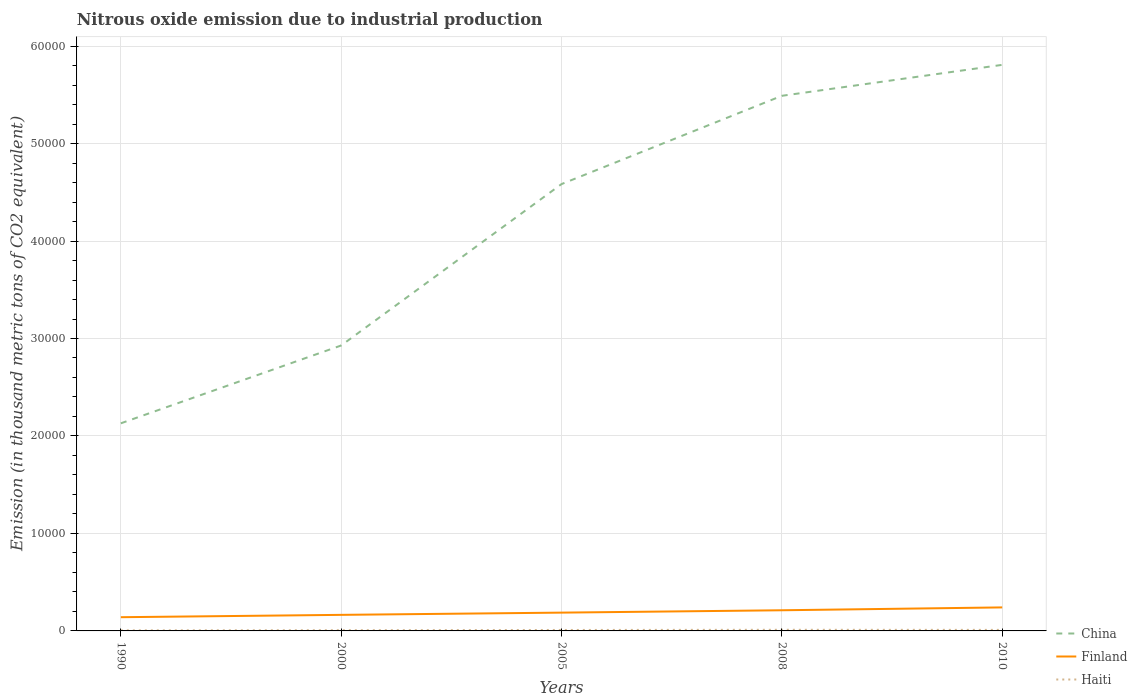Does the line corresponding to China intersect with the line corresponding to Haiti?
Make the answer very short. No. Across all years, what is the maximum amount of nitrous oxide emitted in Finland?
Your answer should be compact. 1406.8. What is the total amount of nitrous oxide emitted in Haiti in the graph?
Ensure brevity in your answer.  -23.2. What is the difference between the highest and the second highest amount of nitrous oxide emitted in Finland?
Keep it short and to the point. 1005.6. Is the amount of nitrous oxide emitted in China strictly greater than the amount of nitrous oxide emitted in Haiti over the years?
Provide a short and direct response. No. How many lines are there?
Keep it short and to the point. 3. Are the values on the major ticks of Y-axis written in scientific E-notation?
Your response must be concise. No. Does the graph contain grids?
Your response must be concise. Yes. Where does the legend appear in the graph?
Provide a short and direct response. Bottom right. How many legend labels are there?
Make the answer very short. 3. How are the legend labels stacked?
Offer a very short reply. Vertical. What is the title of the graph?
Give a very brief answer. Nitrous oxide emission due to industrial production. Does "Solomon Islands" appear as one of the legend labels in the graph?
Provide a short and direct response. No. What is the label or title of the X-axis?
Your response must be concise. Years. What is the label or title of the Y-axis?
Give a very brief answer. Emission (in thousand metric tons of CO2 equivalent). What is the Emission (in thousand metric tons of CO2 equivalent) of China in 1990?
Ensure brevity in your answer.  2.13e+04. What is the Emission (in thousand metric tons of CO2 equivalent) in Finland in 1990?
Keep it short and to the point. 1406.8. What is the Emission (in thousand metric tons of CO2 equivalent) in Haiti in 1990?
Your answer should be compact. 56.6. What is the Emission (in thousand metric tons of CO2 equivalent) of China in 2000?
Provide a short and direct response. 2.93e+04. What is the Emission (in thousand metric tons of CO2 equivalent) in Finland in 2000?
Keep it short and to the point. 1648.4. What is the Emission (in thousand metric tons of CO2 equivalent) in Haiti in 2000?
Your answer should be very brief. 73.8. What is the Emission (in thousand metric tons of CO2 equivalent) in China in 2005?
Your answer should be compact. 4.58e+04. What is the Emission (in thousand metric tons of CO2 equivalent) of Finland in 2005?
Offer a very short reply. 1876.3. What is the Emission (in thousand metric tons of CO2 equivalent) of Haiti in 2005?
Make the answer very short. 97. What is the Emission (in thousand metric tons of CO2 equivalent) of China in 2008?
Make the answer very short. 5.49e+04. What is the Emission (in thousand metric tons of CO2 equivalent) of Finland in 2008?
Offer a very short reply. 2118.7. What is the Emission (in thousand metric tons of CO2 equivalent) of Haiti in 2008?
Make the answer very short. 116. What is the Emission (in thousand metric tons of CO2 equivalent) in China in 2010?
Offer a terse response. 5.81e+04. What is the Emission (in thousand metric tons of CO2 equivalent) in Finland in 2010?
Offer a terse response. 2412.4. What is the Emission (in thousand metric tons of CO2 equivalent) of Haiti in 2010?
Offer a very short reply. 105.8. Across all years, what is the maximum Emission (in thousand metric tons of CO2 equivalent) of China?
Give a very brief answer. 5.81e+04. Across all years, what is the maximum Emission (in thousand metric tons of CO2 equivalent) in Finland?
Provide a succinct answer. 2412.4. Across all years, what is the maximum Emission (in thousand metric tons of CO2 equivalent) in Haiti?
Offer a very short reply. 116. Across all years, what is the minimum Emission (in thousand metric tons of CO2 equivalent) of China?
Provide a short and direct response. 2.13e+04. Across all years, what is the minimum Emission (in thousand metric tons of CO2 equivalent) of Finland?
Ensure brevity in your answer.  1406.8. Across all years, what is the minimum Emission (in thousand metric tons of CO2 equivalent) in Haiti?
Give a very brief answer. 56.6. What is the total Emission (in thousand metric tons of CO2 equivalent) of China in the graph?
Your answer should be very brief. 2.09e+05. What is the total Emission (in thousand metric tons of CO2 equivalent) in Finland in the graph?
Your response must be concise. 9462.6. What is the total Emission (in thousand metric tons of CO2 equivalent) of Haiti in the graph?
Offer a terse response. 449.2. What is the difference between the Emission (in thousand metric tons of CO2 equivalent) in China in 1990 and that in 2000?
Your response must be concise. -7984.9. What is the difference between the Emission (in thousand metric tons of CO2 equivalent) in Finland in 1990 and that in 2000?
Offer a very short reply. -241.6. What is the difference between the Emission (in thousand metric tons of CO2 equivalent) of Haiti in 1990 and that in 2000?
Offer a terse response. -17.2. What is the difference between the Emission (in thousand metric tons of CO2 equivalent) in China in 1990 and that in 2005?
Offer a very short reply. -2.45e+04. What is the difference between the Emission (in thousand metric tons of CO2 equivalent) in Finland in 1990 and that in 2005?
Your answer should be compact. -469.5. What is the difference between the Emission (in thousand metric tons of CO2 equivalent) in Haiti in 1990 and that in 2005?
Your answer should be very brief. -40.4. What is the difference between the Emission (in thousand metric tons of CO2 equivalent) of China in 1990 and that in 2008?
Provide a succinct answer. -3.36e+04. What is the difference between the Emission (in thousand metric tons of CO2 equivalent) in Finland in 1990 and that in 2008?
Provide a succinct answer. -711.9. What is the difference between the Emission (in thousand metric tons of CO2 equivalent) of Haiti in 1990 and that in 2008?
Ensure brevity in your answer.  -59.4. What is the difference between the Emission (in thousand metric tons of CO2 equivalent) of China in 1990 and that in 2010?
Your response must be concise. -3.68e+04. What is the difference between the Emission (in thousand metric tons of CO2 equivalent) of Finland in 1990 and that in 2010?
Your response must be concise. -1005.6. What is the difference between the Emission (in thousand metric tons of CO2 equivalent) of Haiti in 1990 and that in 2010?
Provide a succinct answer. -49.2. What is the difference between the Emission (in thousand metric tons of CO2 equivalent) of China in 2000 and that in 2005?
Your response must be concise. -1.66e+04. What is the difference between the Emission (in thousand metric tons of CO2 equivalent) in Finland in 2000 and that in 2005?
Provide a short and direct response. -227.9. What is the difference between the Emission (in thousand metric tons of CO2 equivalent) in Haiti in 2000 and that in 2005?
Your response must be concise. -23.2. What is the difference between the Emission (in thousand metric tons of CO2 equivalent) in China in 2000 and that in 2008?
Provide a succinct answer. -2.56e+04. What is the difference between the Emission (in thousand metric tons of CO2 equivalent) of Finland in 2000 and that in 2008?
Make the answer very short. -470.3. What is the difference between the Emission (in thousand metric tons of CO2 equivalent) of Haiti in 2000 and that in 2008?
Make the answer very short. -42.2. What is the difference between the Emission (in thousand metric tons of CO2 equivalent) in China in 2000 and that in 2010?
Provide a succinct answer. -2.88e+04. What is the difference between the Emission (in thousand metric tons of CO2 equivalent) in Finland in 2000 and that in 2010?
Provide a succinct answer. -764. What is the difference between the Emission (in thousand metric tons of CO2 equivalent) in Haiti in 2000 and that in 2010?
Ensure brevity in your answer.  -32. What is the difference between the Emission (in thousand metric tons of CO2 equivalent) of China in 2005 and that in 2008?
Keep it short and to the point. -9056.8. What is the difference between the Emission (in thousand metric tons of CO2 equivalent) in Finland in 2005 and that in 2008?
Provide a short and direct response. -242.4. What is the difference between the Emission (in thousand metric tons of CO2 equivalent) of Haiti in 2005 and that in 2008?
Offer a very short reply. -19. What is the difference between the Emission (in thousand metric tons of CO2 equivalent) of China in 2005 and that in 2010?
Ensure brevity in your answer.  -1.22e+04. What is the difference between the Emission (in thousand metric tons of CO2 equivalent) in Finland in 2005 and that in 2010?
Your answer should be very brief. -536.1. What is the difference between the Emission (in thousand metric tons of CO2 equivalent) of Haiti in 2005 and that in 2010?
Your response must be concise. -8.8. What is the difference between the Emission (in thousand metric tons of CO2 equivalent) of China in 2008 and that in 2010?
Ensure brevity in your answer.  -3175.5. What is the difference between the Emission (in thousand metric tons of CO2 equivalent) of Finland in 2008 and that in 2010?
Provide a short and direct response. -293.7. What is the difference between the Emission (in thousand metric tons of CO2 equivalent) in Haiti in 2008 and that in 2010?
Ensure brevity in your answer.  10.2. What is the difference between the Emission (in thousand metric tons of CO2 equivalent) of China in 1990 and the Emission (in thousand metric tons of CO2 equivalent) of Finland in 2000?
Keep it short and to the point. 1.97e+04. What is the difference between the Emission (in thousand metric tons of CO2 equivalent) of China in 1990 and the Emission (in thousand metric tons of CO2 equivalent) of Haiti in 2000?
Make the answer very short. 2.12e+04. What is the difference between the Emission (in thousand metric tons of CO2 equivalent) of Finland in 1990 and the Emission (in thousand metric tons of CO2 equivalent) of Haiti in 2000?
Give a very brief answer. 1333. What is the difference between the Emission (in thousand metric tons of CO2 equivalent) of China in 1990 and the Emission (in thousand metric tons of CO2 equivalent) of Finland in 2005?
Your answer should be compact. 1.94e+04. What is the difference between the Emission (in thousand metric tons of CO2 equivalent) of China in 1990 and the Emission (in thousand metric tons of CO2 equivalent) of Haiti in 2005?
Provide a succinct answer. 2.12e+04. What is the difference between the Emission (in thousand metric tons of CO2 equivalent) in Finland in 1990 and the Emission (in thousand metric tons of CO2 equivalent) in Haiti in 2005?
Provide a short and direct response. 1309.8. What is the difference between the Emission (in thousand metric tons of CO2 equivalent) of China in 1990 and the Emission (in thousand metric tons of CO2 equivalent) of Finland in 2008?
Make the answer very short. 1.92e+04. What is the difference between the Emission (in thousand metric tons of CO2 equivalent) in China in 1990 and the Emission (in thousand metric tons of CO2 equivalent) in Haiti in 2008?
Give a very brief answer. 2.12e+04. What is the difference between the Emission (in thousand metric tons of CO2 equivalent) of Finland in 1990 and the Emission (in thousand metric tons of CO2 equivalent) of Haiti in 2008?
Your answer should be compact. 1290.8. What is the difference between the Emission (in thousand metric tons of CO2 equivalent) of China in 1990 and the Emission (in thousand metric tons of CO2 equivalent) of Finland in 2010?
Make the answer very short. 1.89e+04. What is the difference between the Emission (in thousand metric tons of CO2 equivalent) in China in 1990 and the Emission (in thousand metric tons of CO2 equivalent) in Haiti in 2010?
Your answer should be compact. 2.12e+04. What is the difference between the Emission (in thousand metric tons of CO2 equivalent) of Finland in 1990 and the Emission (in thousand metric tons of CO2 equivalent) of Haiti in 2010?
Your answer should be very brief. 1301. What is the difference between the Emission (in thousand metric tons of CO2 equivalent) of China in 2000 and the Emission (in thousand metric tons of CO2 equivalent) of Finland in 2005?
Offer a very short reply. 2.74e+04. What is the difference between the Emission (in thousand metric tons of CO2 equivalent) in China in 2000 and the Emission (in thousand metric tons of CO2 equivalent) in Haiti in 2005?
Provide a short and direct response. 2.92e+04. What is the difference between the Emission (in thousand metric tons of CO2 equivalent) in Finland in 2000 and the Emission (in thousand metric tons of CO2 equivalent) in Haiti in 2005?
Give a very brief answer. 1551.4. What is the difference between the Emission (in thousand metric tons of CO2 equivalent) in China in 2000 and the Emission (in thousand metric tons of CO2 equivalent) in Finland in 2008?
Make the answer very short. 2.72e+04. What is the difference between the Emission (in thousand metric tons of CO2 equivalent) of China in 2000 and the Emission (in thousand metric tons of CO2 equivalent) of Haiti in 2008?
Your answer should be very brief. 2.92e+04. What is the difference between the Emission (in thousand metric tons of CO2 equivalent) in Finland in 2000 and the Emission (in thousand metric tons of CO2 equivalent) in Haiti in 2008?
Ensure brevity in your answer.  1532.4. What is the difference between the Emission (in thousand metric tons of CO2 equivalent) of China in 2000 and the Emission (in thousand metric tons of CO2 equivalent) of Finland in 2010?
Your answer should be compact. 2.69e+04. What is the difference between the Emission (in thousand metric tons of CO2 equivalent) in China in 2000 and the Emission (in thousand metric tons of CO2 equivalent) in Haiti in 2010?
Make the answer very short. 2.92e+04. What is the difference between the Emission (in thousand metric tons of CO2 equivalent) of Finland in 2000 and the Emission (in thousand metric tons of CO2 equivalent) of Haiti in 2010?
Offer a terse response. 1542.6. What is the difference between the Emission (in thousand metric tons of CO2 equivalent) of China in 2005 and the Emission (in thousand metric tons of CO2 equivalent) of Finland in 2008?
Keep it short and to the point. 4.37e+04. What is the difference between the Emission (in thousand metric tons of CO2 equivalent) in China in 2005 and the Emission (in thousand metric tons of CO2 equivalent) in Haiti in 2008?
Keep it short and to the point. 4.57e+04. What is the difference between the Emission (in thousand metric tons of CO2 equivalent) in Finland in 2005 and the Emission (in thousand metric tons of CO2 equivalent) in Haiti in 2008?
Provide a short and direct response. 1760.3. What is the difference between the Emission (in thousand metric tons of CO2 equivalent) in China in 2005 and the Emission (in thousand metric tons of CO2 equivalent) in Finland in 2010?
Ensure brevity in your answer.  4.34e+04. What is the difference between the Emission (in thousand metric tons of CO2 equivalent) in China in 2005 and the Emission (in thousand metric tons of CO2 equivalent) in Haiti in 2010?
Your answer should be compact. 4.57e+04. What is the difference between the Emission (in thousand metric tons of CO2 equivalent) in Finland in 2005 and the Emission (in thousand metric tons of CO2 equivalent) in Haiti in 2010?
Make the answer very short. 1770.5. What is the difference between the Emission (in thousand metric tons of CO2 equivalent) in China in 2008 and the Emission (in thousand metric tons of CO2 equivalent) in Finland in 2010?
Your answer should be very brief. 5.25e+04. What is the difference between the Emission (in thousand metric tons of CO2 equivalent) in China in 2008 and the Emission (in thousand metric tons of CO2 equivalent) in Haiti in 2010?
Ensure brevity in your answer.  5.48e+04. What is the difference between the Emission (in thousand metric tons of CO2 equivalent) in Finland in 2008 and the Emission (in thousand metric tons of CO2 equivalent) in Haiti in 2010?
Your response must be concise. 2012.9. What is the average Emission (in thousand metric tons of CO2 equivalent) of China per year?
Offer a terse response. 4.19e+04. What is the average Emission (in thousand metric tons of CO2 equivalent) of Finland per year?
Give a very brief answer. 1892.52. What is the average Emission (in thousand metric tons of CO2 equivalent) of Haiti per year?
Your response must be concise. 89.84. In the year 1990, what is the difference between the Emission (in thousand metric tons of CO2 equivalent) in China and Emission (in thousand metric tons of CO2 equivalent) in Finland?
Give a very brief answer. 1.99e+04. In the year 1990, what is the difference between the Emission (in thousand metric tons of CO2 equivalent) of China and Emission (in thousand metric tons of CO2 equivalent) of Haiti?
Offer a terse response. 2.12e+04. In the year 1990, what is the difference between the Emission (in thousand metric tons of CO2 equivalent) in Finland and Emission (in thousand metric tons of CO2 equivalent) in Haiti?
Ensure brevity in your answer.  1350.2. In the year 2000, what is the difference between the Emission (in thousand metric tons of CO2 equivalent) of China and Emission (in thousand metric tons of CO2 equivalent) of Finland?
Your answer should be very brief. 2.76e+04. In the year 2000, what is the difference between the Emission (in thousand metric tons of CO2 equivalent) in China and Emission (in thousand metric tons of CO2 equivalent) in Haiti?
Provide a succinct answer. 2.92e+04. In the year 2000, what is the difference between the Emission (in thousand metric tons of CO2 equivalent) of Finland and Emission (in thousand metric tons of CO2 equivalent) of Haiti?
Your answer should be very brief. 1574.6. In the year 2005, what is the difference between the Emission (in thousand metric tons of CO2 equivalent) in China and Emission (in thousand metric tons of CO2 equivalent) in Finland?
Your response must be concise. 4.40e+04. In the year 2005, what is the difference between the Emission (in thousand metric tons of CO2 equivalent) of China and Emission (in thousand metric tons of CO2 equivalent) of Haiti?
Provide a succinct answer. 4.57e+04. In the year 2005, what is the difference between the Emission (in thousand metric tons of CO2 equivalent) in Finland and Emission (in thousand metric tons of CO2 equivalent) in Haiti?
Your answer should be very brief. 1779.3. In the year 2008, what is the difference between the Emission (in thousand metric tons of CO2 equivalent) of China and Emission (in thousand metric tons of CO2 equivalent) of Finland?
Give a very brief answer. 5.28e+04. In the year 2008, what is the difference between the Emission (in thousand metric tons of CO2 equivalent) in China and Emission (in thousand metric tons of CO2 equivalent) in Haiti?
Offer a terse response. 5.48e+04. In the year 2008, what is the difference between the Emission (in thousand metric tons of CO2 equivalent) in Finland and Emission (in thousand metric tons of CO2 equivalent) in Haiti?
Your response must be concise. 2002.7. In the year 2010, what is the difference between the Emission (in thousand metric tons of CO2 equivalent) of China and Emission (in thousand metric tons of CO2 equivalent) of Finland?
Make the answer very short. 5.57e+04. In the year 2010, what is the difference between the Emission (in thousand metric tons of CO2 equivalent) of China and Emission (in thousand metric tons of CO2 equivalent) of Haiti?
Offer a very short reply. 5.80e+04. In the year 2010, what is the difference between the Emission (in thousand metric tons of CO2 equivalent) of Finland and Emission (in thousand metric tons of CO2 equivalent) of Haiti?
Offer a very short reply. 2306.6. What is the ratio of the Emission (in thousand metric tons of CO2 equivalent) of China in 1990 to that in 2000?
Keep it short and to the point. 0.73. What is the ratio of the Emission (in thousand metric tons of CO2 equivalent) in Finland in 1990 to that in 2000?
Keep it short and to the point. 0.85. What is the ratio of the Emission (in thousand metric tons of CO2 equivalent) of Haiti in 1990 to that in 2000?
Offer a terse response. 0.77. What is the ratio of the Emission (in thousand metric tons of CO2 equivalent) in China in 1990 to that in 2005?
Make the answer very short. 0.46. What is the ratio of the Emission (in thousand metric tons of CO2 equivalent) of Finland in 1990 to that in 2005?
Offer a very short reply. 0.75. What is the ratio of the Emission (in thousand metric tons of CO2 equivalent) of Haiti in 1990 to that in 2005?
Provide a short and direct response. 0.58. What is the ratio of the Emission (in thousand metric tons of CO2 equivalent) in China in 1990 to that in 2008?
Provide a short and direct response. 0.39. What is the ratio of the Emission (in thousand metric tons of CO2 equivalent) in Finland in 1990 to that in 2008?
Offer a terse response. 0.66. What is the ratio of the Emission (in thousand metric tons of CO2 equivalent) in Haiti in 1990 to that in 2008?
Offer a terse response. 0.49. What is the ratio of the Emission (in thousand metric tons of CO2 equivalent) in China in 1990 to that in 2010?
Provide a short and direct response. 0.37. What is the ratio of the Emission (in thousand metric tons of CO2 equivalent) of Finland in 1990 to that in 2010?
Provide a succinct answer. 0.58. What is the ratio of the Emission (in thousand metric tons of CO2 equivalent) in Haiti in 1990 to that in 2010?
Offer a very short reply. 0.54. What is the ratio of the Emission (in thousand metric tons of CO2 equivalent) in China in 2000 to that in 2005?
Your response must be concise. 0.64. What is the ratio of the Emission (in thousand metric tons of CO2 equivalent) of Finland in 2000 to that in 2005?
Offer a very short reply. 0.88. What is the ratio of the Emission (in thousand metric tons of CO2 equivalent) in Haiti in 2000 to that in 2005?
Keep it short and to the point. 0.76. What is the ratio of the Emission (in thousand metric tons of CO2 equivalent) in China in 2000 to that in 2008?
Offer a very short reply. 0.53. What is the ratio of the Emission (in thousand metric tons of CO2 equivalent) in Finland in 2000 to that in 2008?
Offer a very short reply. 0.78. What is the ratio of the Emission (in thousand metric tons of CO2 equivalent) in Haiti in 2000 to that in 2008?
Your answer should be very brief. 0.64. What is the ratio of the Emission (in thousand metric tons of CO2 equivalent) of China in 2000 to that in 2010?
Offer a terse response. 0.5. What is the ratio of the Emission (in thousand metric tons of CO2 equivalent) of Finland in 2000 to that in 2010?
Provide a succinct answer. 0.68. What is the ratio of the Emission (in thousand metric tons of CO2 equivalent) of Haiti in 2000 to that in 2010?
Provide a succinct answer. 0.7. What is the ratio of the Emission (in thousand metric tons of CO2 equivalent) of China in 2005 to that in 2008?
Your response must be concise. 0.83. What is the ratio of the Emission (in thousand metric tons of CO2 equivalent) of Finland in 2005 to that in 2008?
Provide a short and direct response. 0.89. What is the ratio of the Emission (in thousand metric tons of CO2 equivalent) of Haiti in 2005 to that in 2008?
Your answer should be compact. 0.84. What is the ratio of the Emission (in thousand metric tons of CO2 equivalent) of China in 2005 to that in 2010?
Provide a succinct answer. 0.79. What is the ratio of the Emission (in thousand metric tons of CO2 equivalent) of Finland in 2005 to that in 2010?
Your answer should be compact. 0.78. What is the ratio of the Emission (in thousand metric tons of CO2 equivalent) of Haiti in 2005 to that in 2010?
Provide a short and direct response. 0.92. What is the ratio of the Emission (in thousand metric tons of CO2 equivalent) in China in 2008 to that in 2010?
Provide a succinct answer. 0.95. What is the ratio of the Emission (in thousand metric tons of CO2 equivalent) of Finland in 2008 to that in 2010?
Your answer should be compact. 0.88. What is the ratio of the Emission (in thousand metric tons of CO2 equivalent) in Haiti in 2008 to that in 2010?
Give a very brief answer. 1.1. What is the difference between the highest and the second highest Emission (in thousand metric tons of CO2 equivalent) of China?
Keep it short and to the point. 3175.5. What is the difference between the highest and the second highest Emission (in thousand metric tons of CO2 equivalent) in Finland?
Provide a short and direct response. 293.7. What is the difference between the highest and the second highest Emission (in thousand metric tons of CO2 equivalent) of Haiti?
Keep it short and to the point. 10.2. What is the difference between the highest and the lowest Emission (in thousand metric tons of CO2 equivalent) of China?
Give a very brief answer. 3.68e+04. What is the difference between the highest and the lowest Emission (in thousand metric tons of CO2 equivalent) of Finland?
Offer a terse response. 1005.6. What is the difference between the highest and the lowest Emission (in thousand metric tons of CO2 equivalent) of Haiti?
Provide a short and direct response. 59.4. 